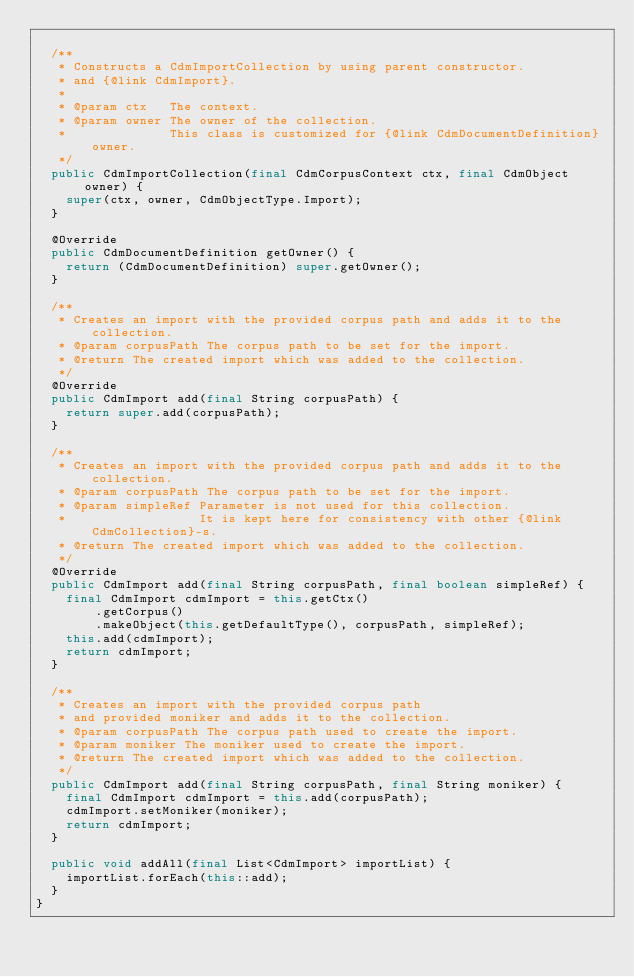Convert code to text. <code><loc_0><loc_0><loc_500><loc_500><_Java_>
  /**
   * Constructs a CdmImportCollection by using parent constructor.
   * and {@link CdmImport}.
   *
   * @param ctx   The context.
   * @param owner The owner of the collection.
   *              This class is customized for {@link CdmDocumentDefinition} owner.
   */
  public CdmImportCollection(final CdmCorpusContext ctx, final CdmObject owner) {
    super(ctx, owner, CdmObjectType.Import);
  }

  @Override
  public CdmDocumentDefinition getOwner() {
    return (CdmDocumentDefinition) super.getOwner();
  }

  /**
   * Creates an import with the provided corpus path and adds it to the collection.
   * @param corpusPath The corpus path to be set for the import.
   * @return The created import which was added to the collection.
   */
  @Override
  public CdmImport add(final String corpusPath) {
    return super.add(corpusPath);
  }

  /**
   * Creates an import with the provided corpus path and adds it to the collection.
   * @param corpusPath The corpus path to be set for the import.
   * @param simpleRef Parameter is not used for this collection.
   *                  It is kept here for consistency with other {@link CdmCollection}-s.
   * @return The created import which was added to the collection.
   */
  @Override
  public CdmImport add(final String corpusPath, final boolean simpleRef) {
    final CdmImport cdmImport = this.getCtx()
        .getCorpus()
        .makeObject(this.getDefaultType(), corpusPath, simpleRef);
    this.add(cdmImport);
    return cdmImport;
  }

  /**
   * Creates an import with the provided corpus path
   * and provided moniker and adds it to the collection.
   * @param corpusPath The corpus path used to create the import.
   * @param moniker The moniker used to create the import.
   * @return The created import which was added to the collection.
   */
  public CdmImport add(final String corpusPath, final String moniker) {
    final CdmImport cdmImport = this.add(corpusPath);
    cdmImport.setMoniker(moniker);
    return cdmImport;
  }

  public void addAll(final List<CdmImport> importList) {
    importList.forEach(this::add);
  }
}
</code> 